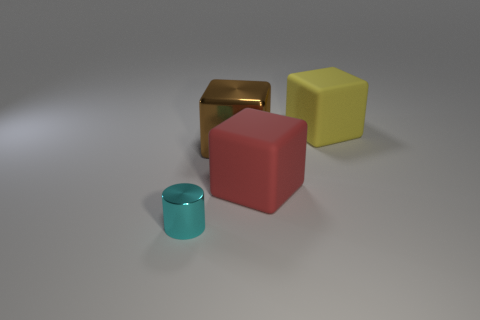The other metallic thing that is the same shape as the big red object is what color?
Offer a terse response. Brown. What is the material of the object that is both in front of the brown thing and to the right of the tiny metal cylinder?
Provide a short and direct response. Rubber. Are the cube that is to the right of the red matte block and the block in front of the big shiny cube made of the same material?
Provide a short and direct response. Yes. What size is the cyan metallic thing?
Your response must be concise. Small. There is a cylinder; what number of matte things are right of it?
Provide a succinct answer. 2. What color is the large object that is in front of the metal thing behind the small cylinder?
Your answer should be compact. Red. Is there anything else that has the same shape as the cyan metal thing?
Provide a succinct answer. No. Are there an equal number of cyan metallic cylinders that are behind the small metallic object and objects that are on the right side of the yellow matte block?
Ensure brevity in your answer.  Yes. What number of balls are either large green matte objects or big yellow things?
Provide a short and direct response. 0. How many other objects are there of the same material as the brown cube?
Make the answer very short. 1. 